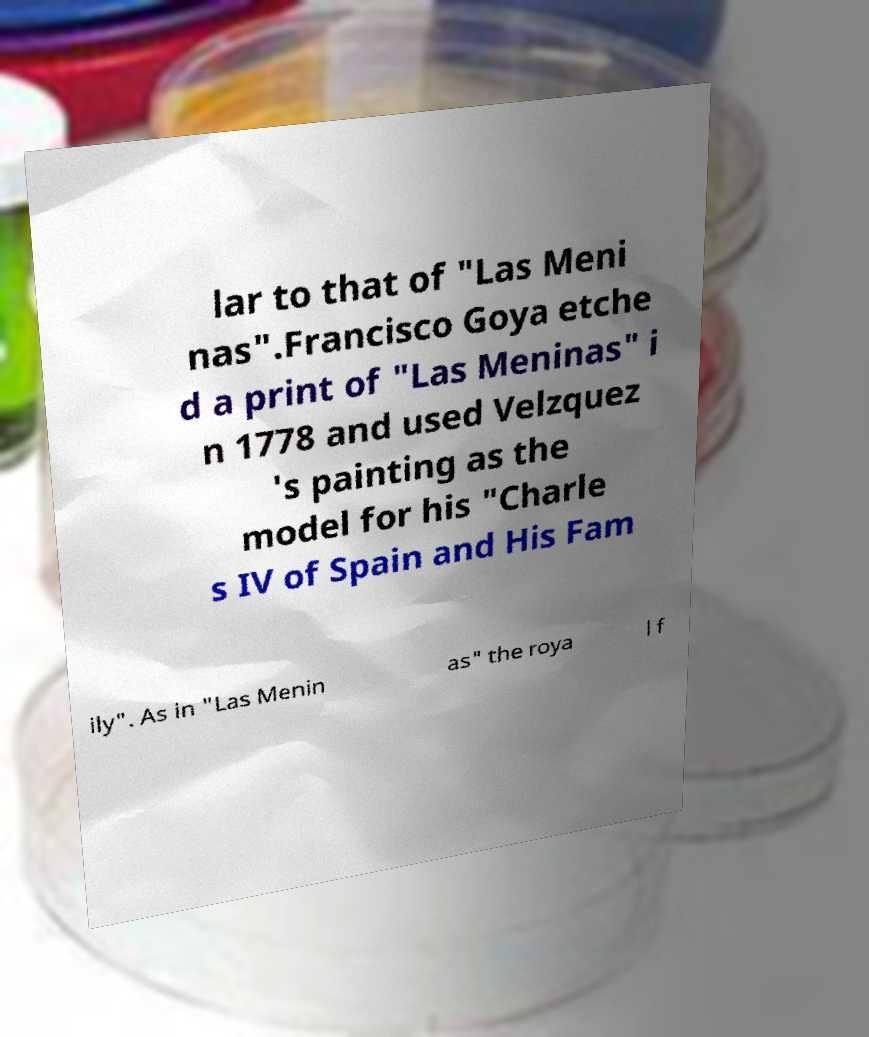Please read and relay the text visible in this image. What does it say? lar to that of "Las Meni nas".Francisco Goya etche d a print of "Las Meninas" i n 1778 and used Velzquez 's painting as the model for his "Charle s IV of Spain and His Fam ily". As in "Las Menin as" the roya l f 